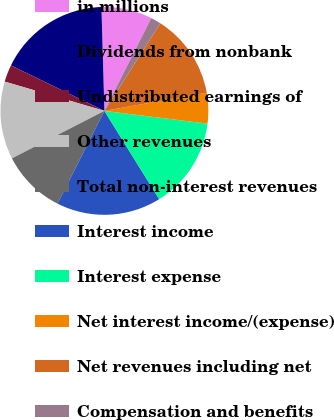Convert chart. <chart><loc_0><loc_0><loc_500><loc_500><pie_chart><fcel>in millions<fcel>Dividends from nonbank<fcel>Undistributed earnings of<fcel>Other revenues<fcel>Total non-interest revenues<fcel>Interest income<fcel>Interest expense<fcel>Net interest income/(expense)<fcel>Net revenues including net<fcel>Compensation and benefits<nl><fcel>7.9%<fcel>17.34%<fcel>2.66%<fcel>12.1%<fcel>10.0%<fcel>16.29%<fcel>14.2%<fcel>4.76%<fcel>13.15%<fcel>1.61%<nl></chart> 